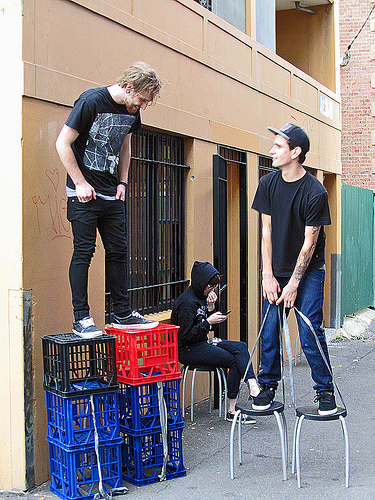<image>
Can you confirm if the man is on the crate? Yes. Looking at the image, I can see the man is positioned on top of the crate, with the crate providing support. Is there a wall behind the person? Yes. From this viewpoint, the wall is positioned behind the person, with the person partially or fully occluding the wall. Is there a stool behind the person? No. The stool is not behind the person. From this viewpoint, the stool appears to be positioned elsewhere in the scene. Is there a shirt above the basket? Yes. The shirt is positioned above the basket in the vertical space, higher up in the scene. 